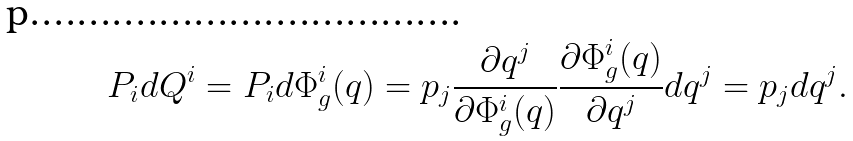<formula> <loc_0><loc_0><loc_500><loc_500>P _ { i } d Q ^ { i } = P _ { i } d \Phi _ { g } ^ { i } ( q ) = p _ { j } \frac { \partial q ^ { j } } { \partial \Phi _ { g } ^ { i } ( q ) } \frac { \partial \Phi _ { g } ^ { i } ( q ) } { \partial q ^ { j } } d q ^ { j } = p _ { j } d q ^ { j } .</formula> 